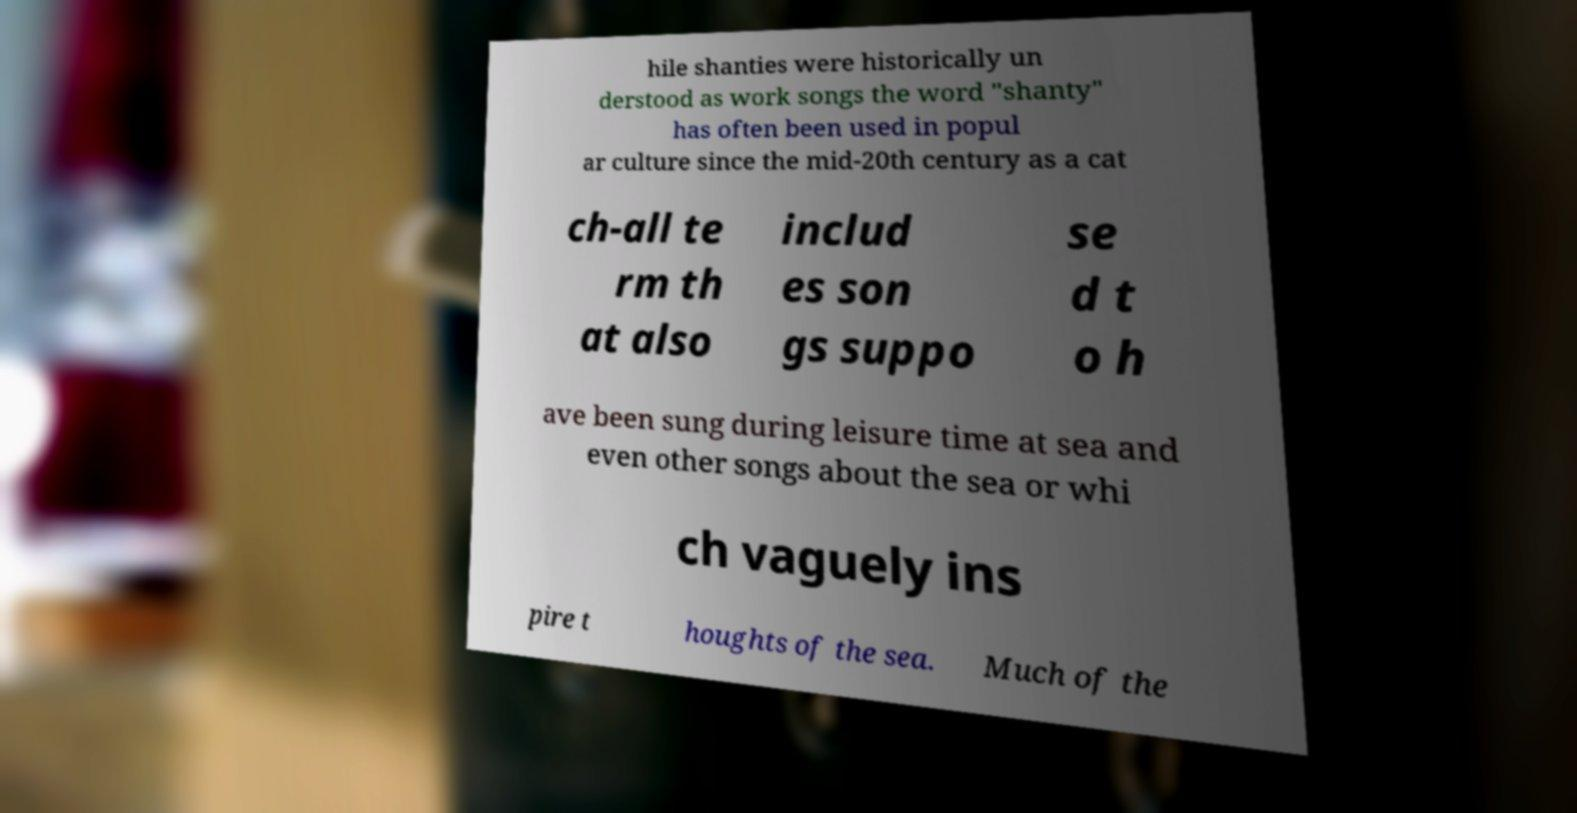What messages or text are displayed in this image? I need them in a readable, typed format. hile shanties were historically un derstood as work songs the word "shanty" has often been used in popul ar culture since the mid-20th century as a cat ch-all te rm th at also includ es son gs suppo se d t o h ave been sung during leisure time at sea and even other songs about the sea or whi ch vaguely ins pire t houghts of the sea. Much of the 